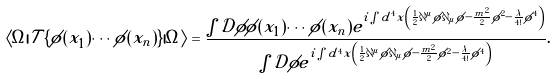<formula> <loc_0><loc_0><loc_500><loc_500>\langle \Omega | { \mathcal { T } } \{ { \phi } ( x _ { 1 } ) \cdots { \phi } ( x _ { n } ) \} | \Omega \rangle = { \frac { \int { \mathcal { D } } \phi \phi ( x _ { 1 } ) \cdots \phi ( x _ { n } ) e ^ { i \int d ^ { 4 } x \left ( { \frac { 1 } { 2 } } \partial ^ { \mu } \phi \partial _ { \mu } \phi - { \frac { m ^ { 2 } } { 2 } } \phi ^ { 2 } - { \frac { \lambda } { 4 ! } } \phi ^ { 4 } \right ) } } { \int { \mathcal { D } } \phi e ^ { i \int d ^ { 4 } x \left ( { \frac { 1 } { 2 } } \partial ^ { \mu } \phi \partial _ { \mu } \phi - { \frac { m ^ { 2 } } { 2 } } \phi ^ { 2 } - { \frac { \lambda } { 4 ! } } \phi ^ { 4 } \right ) } } } .</formula> 